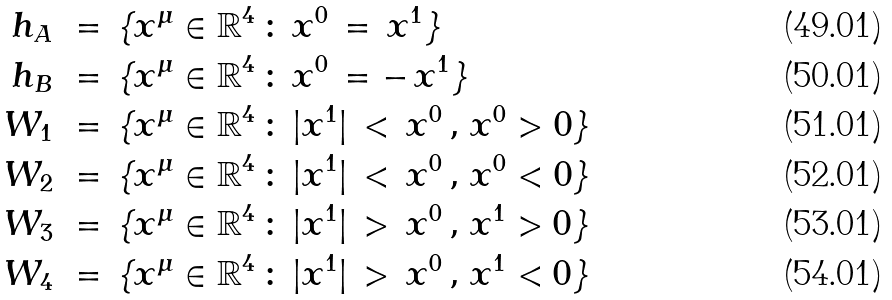<formula> <loc_0><loc_0><loc_500><loc_500>h _ { A } \, & \, = \, \{ x ^ { \mu } \in { \mathbb { R } } ^ { 4 } \, \colon \, x ^ { 0 } \, = \, x ^ { 1 } \} \\ h _ { B } \, & \, = \, \{ x ^ { \mu } \in { \mathbb { R } } ^ { 4 } \, \colon \, x ^ { 0 } \, = - \, x ^ { 1 } \} \\ W _ { 1 } \, & \, = \, \{ x ^ { \mu } \in { \mathbb { R } } ^ { 4 } \, \colon \, | x ^ { 1 } | \, < \, x ^ { 0 } \, , \, x ^ { 0 } > 0 \} \\ W _ { 2 } \, & \, = \, \{ x ^ { \mu } \in { \mathbb { R } } ^ { 4 } \, \colon \, | x ^ { 1 } | \, < \, x ^ { 0 } \, , \, x ^ { 0 } < 0 \} \\ W _ { 3 } \, & \, = \, \{ x ^ { \mu } \in { \mathbb { R } } ^ { 4 } \, \colon \, | x ^ { 1 } | \, > \, x ^ { 0 } \, , \, x ^ { 1 } > 0 \} \\ W _ { 4 } \, & \, = \, \{ x ^ { \mu } \in { \mathbb { R } } ^ { 4 } \, \colon \, | x ^ { 1 } | \, > \, x ^ { 0 } \, , \, x ^ { 1 } < 0 \}</formula> 